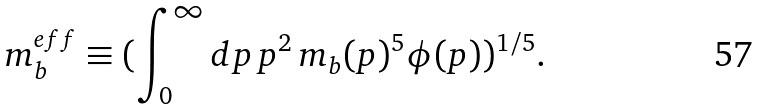<formula> <loc_0><loc_0><loc_500><loc_500>m _ { b } ^ { e f f } \equiv ( \int _ { 0 } ^ { \infty } d p \, p ^ { 2 } \, m _ { b } ( p ) ^ { 5 } \phi ( p ) ) ^ { 1 / 5 } .</formula> 